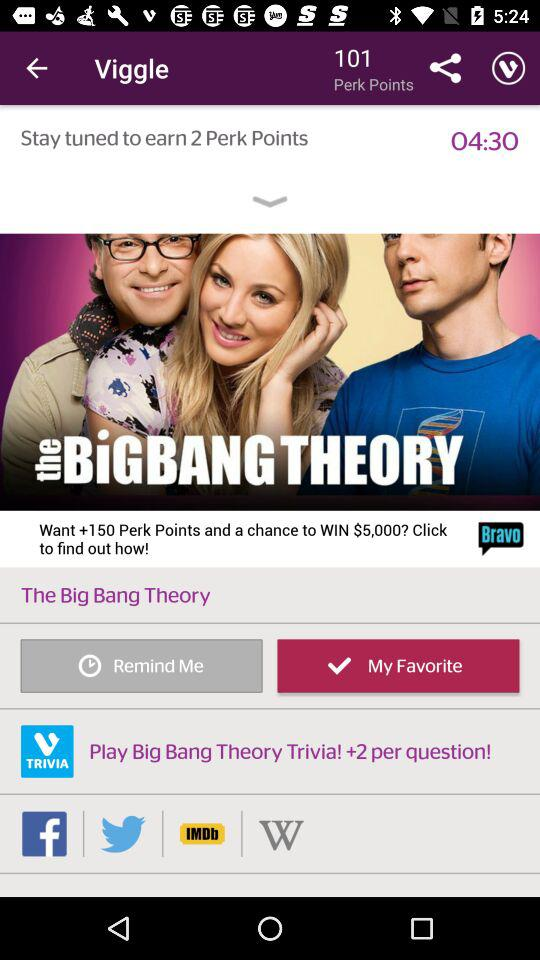How many more minutes until the end of the episode?
Answer the question using a single word or phrase. 04:30 